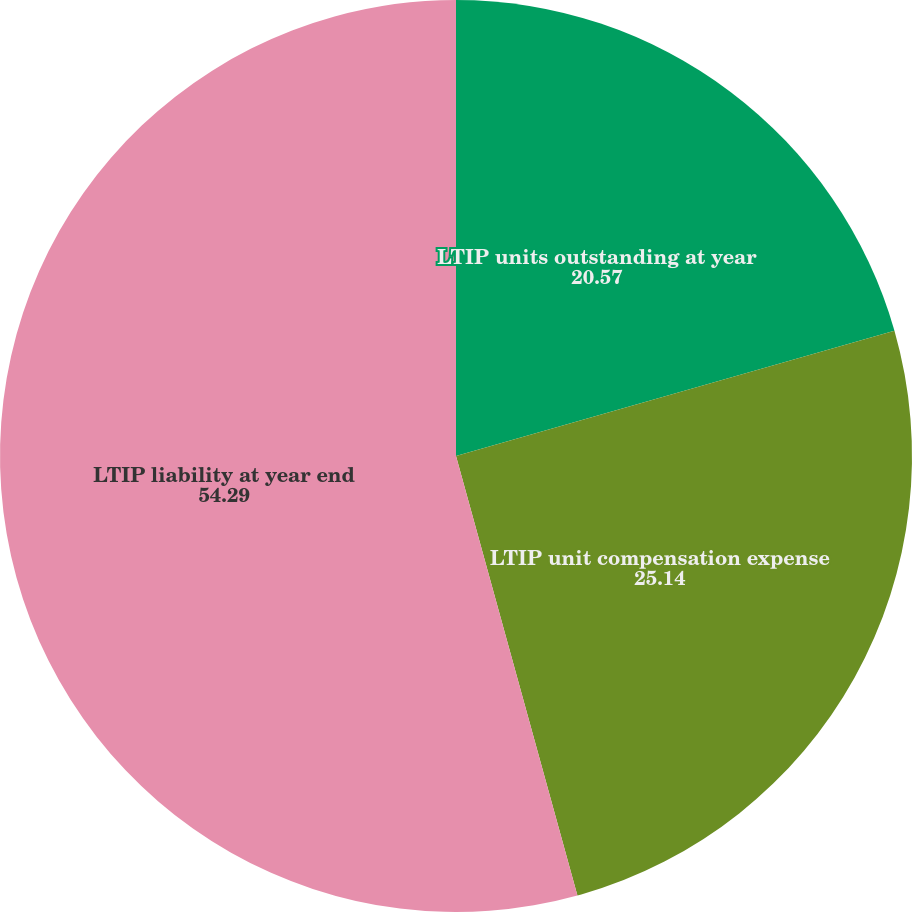Convert chart. <chart><loc_0><loc_0><loc_500><loc_500><pie_chart><fcel>LTIP units outstanding at year<fcel>LTIP unit compensation expense<fcel>LTIP liability at year end<nl><fcel>20.57%<fcel>25.14%<fcel>54.29%<nl></chart> 